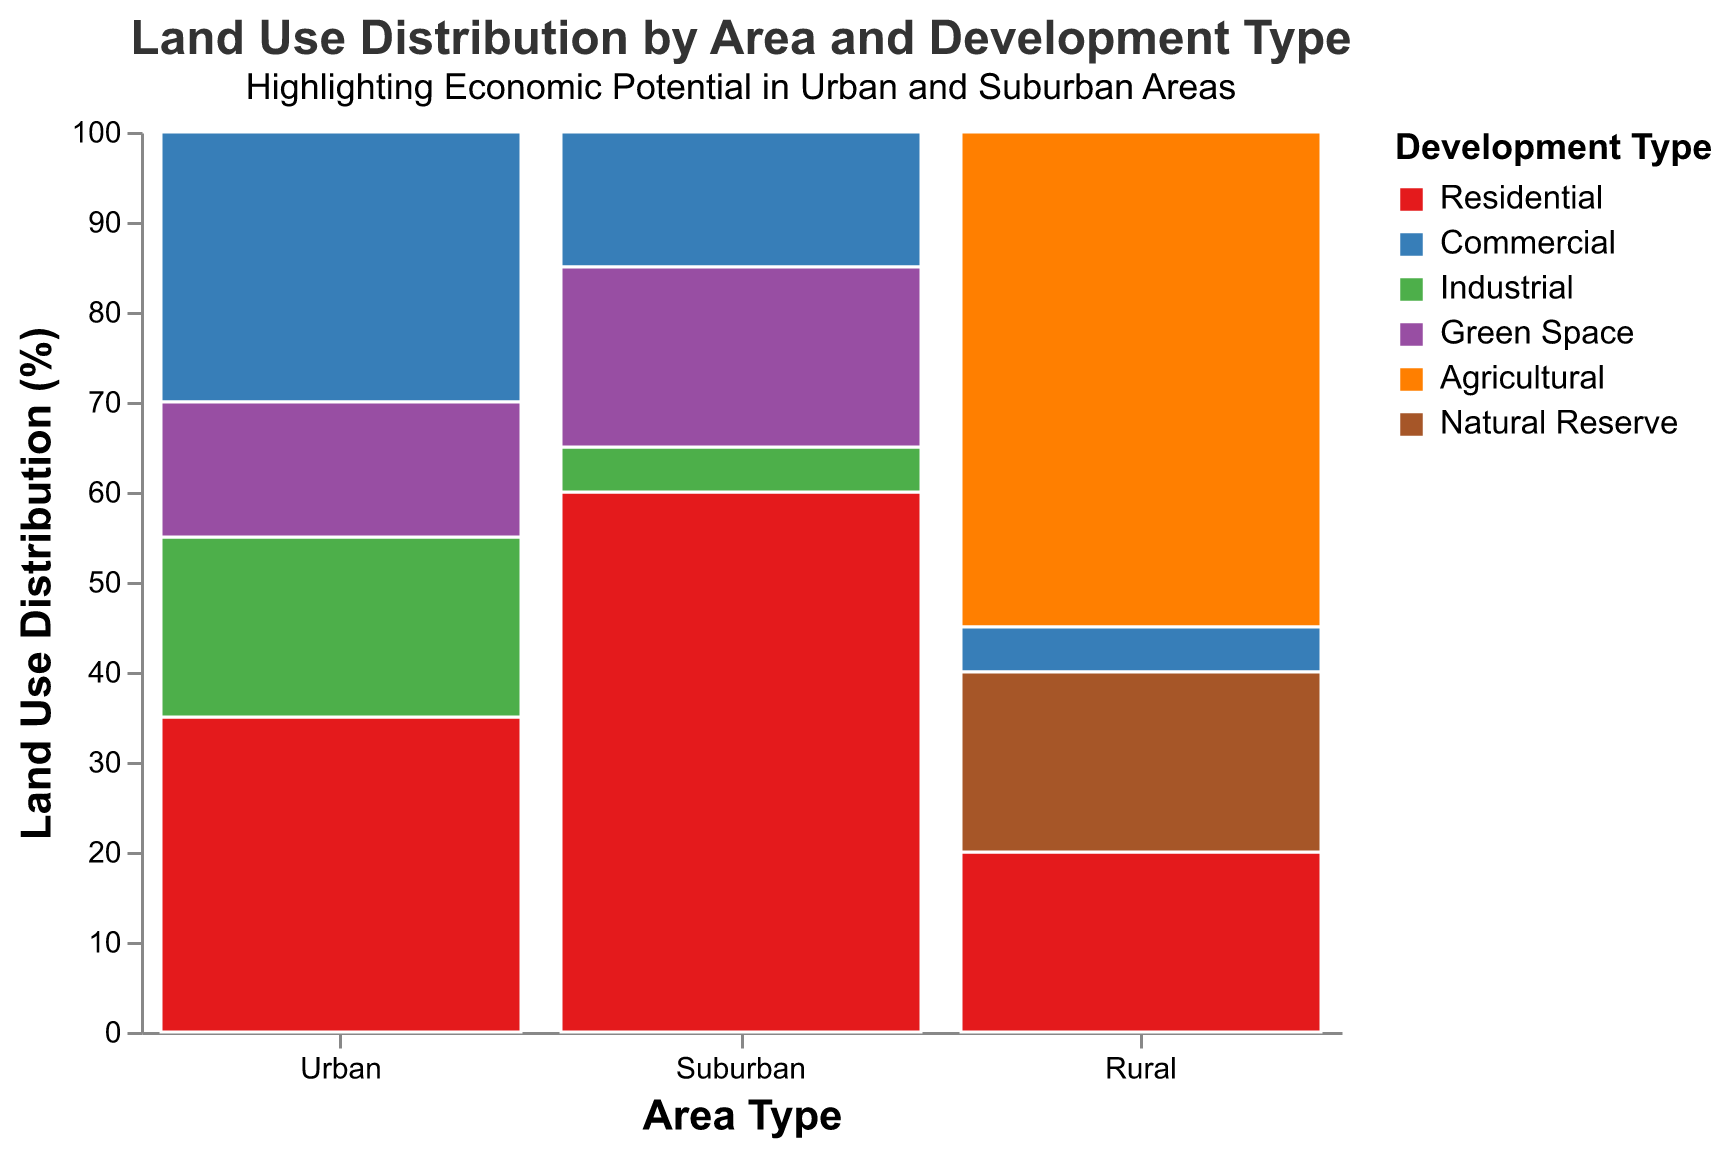What is the highest percentage development type in suburban areas? By looking at the suburban section of the plot and comparing the heights of the bars, we see that residential has the highest bar among all development types in suburban areas, which corresponds to 60%.
Answer: 60% Which area has the most equal distribution of land use among its development types? By comparing the heights of the bars in different areas, we can see that the urban area has the most even distribution among residential (35%), commercial (30%), industrial (20%), and green space (15%).
Answer: Urban How much of the rural area is used for non-agricultural purposes? Sum the percentages of all non-agricultural land uses in rural areas: residential (20%) + commercial (5%) + natural reserve (20%) = 45%.
Answer: 45% What is the combined percentage of green space across all areas? Sum up the percentages of green space in all specified areas: urban (15%) and suburban (20%) = 35%.
Answer: 35% Which development type appears exclusively in rural areas? By reviewing the legend and the distribution, only agricultural and natural reserve development types are found exclusively in rural areas. However, only agricultural is unique to rural while natural reserve also appears in suburban areas under a different classification (green space).
Answer: Agricultural What is the difference in residential land use percentage between the suburban and urban areas? Subtract the residential land use percentage of suburban (60%) from that of urban (35%): 60% - 35% = 25%.
Answer: 25% Consider commercial land use; which area has the highest and which has the lowest percentage? By comparing the heights of the bars categorized as commercial, urban has the highest percentage (30%) and both suburban and rural have the lowest (5% each).
Answer: Urban, Rural/Suburban In rural areas, how much more land is used for agricultural purposes than for residential purposes? Subtract the residential land use percentage (20%) from the agricultural land use percentage (55%): 55% - 20% = 35%.
Answer: 35% What is the ratio of industrial land use between urban and suburban areas? Divide the land use percentage of industrial in urban areas (20%) by that in suburban areas (5%): 20% / 5% = 4.
Answer: 4 If you were to combine the percentage of green space in urban areas with the percentage of natural reserves in rural areas, what would the total be? Add the green space percentage in urban (15%) to the natural reserve percentage in rural (20%): 15% + 20% = 35%.
Answer: 35% 